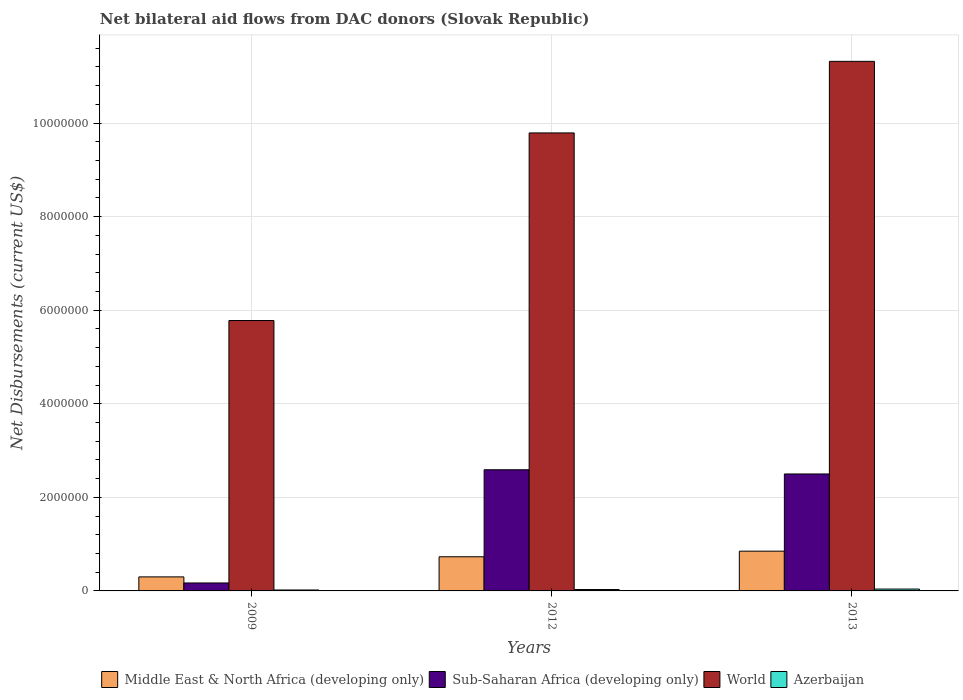How many different coloured bars are there?
Give a very brief answer. 4. What is the label of the 3rd group of bars from the left?
Make the answer very short. 2013. In how many cases, is the number of bars for a given year not equal to the number of legend labels?
Ensure brevity in your answer.  0. What is the net bilateral aid flows in Sub-Saharan Africa (developing only) in 2009?
Ensure brevity in your answer.  1.70e+05. Across all years, what is the maximum net bilateral aid flows in Sub-Saharan Africa (developing only)?
Offer a terse response. 2.59e+06. Across all years, what is the minimum net bilateral aid flows in Middle East & North Africa (developing only)?
Make the answer very short. 3.00e+05. What is the difference between the net bilateral aid flows in Sub-Saharan Africa (developing only) in 2009 and that in 2012?
Make the answer very short. -2.42e+06. What is the difference between the net bilateral aid flows in World in 2009 and the net bilateral aid flows in Sub-Saharan Africa (developing only) in 2012?
Keep it short and to the point. 3.19e+06. What is the average net bilateral aid flows in World per year?
Make the answer very short. 8.96e+06. In the year 2012, what is the difference between the net bilateral aid flows in World and net bilateral aid flows in Azerbaijan?
Keep it short and to the point. 9.76e+06. What is the ratio of the net bilateral aid flows in World in 2009 to that in 2013?
Your answer should be very brief. 0.51. What is the difference between the highest and the second highest net bilateral aid flows in Sub-Saharan Africa (developing only)?
Ensure brevity in your answer.  9.00e+04. What is the difference between the highest and the lowest net bilateral aid flows in Middle East & North Africa (developing only)?
Provide a short and direct response. 5.50e+05. In how many years, is the net bilateral aid flows in Azerbaijan greater than the average net bilateral aid flows in Azerbaijan taken over all years?
Offer a terse response. 1. Is the sum of the net bilateral aid flows in World in 2012 and 2013 greater than the maximum net bilateral aid flows in Middle East & North Africa (developing only) across all years?
Make the answer very short. Yes. What does the 2nd bar from the left in 2012 represents?
Make the answer very short. Sub-Saharan Africa (developing only). Is it the case that in every year, the sum of the net bilateral aid flows in Middle East & North Africa (developing only) and net bilateral aid flows in World is greater than the net bilateral aid flows in Sub-Saharan Africa (developing only)?
Your answer should be very brief. Yes. Are all the bars in the graph horizontal?
Your response must be concise. No. How many years are there in the graph?
Provide a succinct answer. 3. What is the difference between two consecutive major ticks on the Y-axis?
Your answer should be very brief. 2.00e+06. Where does the legend appear in the graph?
Offer a terse response. Bottom center. How many legend labels are there?
Your answer should be compact. 4. What is the title of the graph?
Ensure brevity in your answer.  Net bilateral aid flows from DAC donors (Slovak Republic). What is the label or title of the X-axis?
Give a very brief answer. Years. What is the label or title of the Y-axis?
Make the answer very short. Net Disbursements (current US$). What is the Net Disbursements (current US$) in Sub-Saharan Africa (developing only) in 2009?
Your answer should be very brief. 1.70e+05. What is the Net Disbursements (current US$) in World in 2009?
Offer a very short reply. 5.78e+06. What is the Net Disbursements (current US$) in Azerbaijan in 2009?
Offer a very short reply. 2.00e+04. What is the Net Disbursements (current US$) of Middle East & North Africa (developing only) in 2012?
Give a very brief answer. 7.30e+05. What is the Net Disbursements (current US$) of Sub-Saharan Africa (developing only) in 2012?
Make the answer very short. 2.59e+06. What is the Net Disbursements (current US$) of World in 2012?
Your answer should be very brief. 9.79e+06. What is the Net Disbursements (current US$) of Middle East & North Africa (developing only) in 2013?
Keep it short and to the point. 8.50e+05. What is the Net Disbursements (current US$) in Sub-Saharan Africa (developing only) in 2013?
Provide a short and direct response. 2.50e+06. What is the Net Disbursements (current US$) in World in 2013?
Ensure brevity in your answer.  1.13e+07. What is the Net Disbursements (current US$) of Azerbaijan in 2013?
Give a very brief answer. 4.00e+04. Across all years, what is the maximum Net Disbursements (current US$) in Middle East & North Africa (developing only)?
Offer a very short reply. 8.50e+05. Across all years, what is the maximum Net Disbursements (current US$) of Sub-Saharan Africa (developing only)?
Your response must be concise. 2.59e+06. Across all years, what is the maximum Net Disbursements (current US$) in World?
Make the answer very short. 1.13e+07. Across all years, what is the minimum Net Disbursements (current US$) of World?
Keep it short and to the point. 5.78e+06. Across all years, what is the minimum Net Disbursements (current US$) in Azerbaijan?
Your answer should be compact. 2.00e+04. What is the total Net Disbursements (current US$) of Middle East & North Africa (developing only) in the graph?
Your answer should be compact. 1.88e+06. What is the total Net Disbursements (current US$) of Sub-Saharan Africa (developing only) in the graph?
Your response must be concise. 5.26e+06. What is the total Net Disbursements (current US$) in World in the graph?
Your response must be concise. 2.69e+07. What is the difference between the Net Disbursements (current US$) of Middle East & North Africa (developing only) in 2009 and that in 2012?
Offer a terse response. -4.30e+05. What is the difference between the Net Disbursements (current US$) of Sub-Saharan Africa (developing only) in 2009 and that in 2012?
Ensure brevity in your answer.  -2.42e+06. What is the difference between the Net Disbursements (current US$) of World in 2009 and that in 2012?
Give a very brief answer. -4.01e+06. What is the difference between the Net Disbursements (current US$) of Middle East & North Africa (developing only) in 2009 and that in 2013?
Your answer should be compact. -5.50e+05. What is the difference between the Net Disbursements (current US$) of Sub-Saharan Africa (developing only) in 2009 and that in 2013?
Provide a short and direct response. -2.33e+06. What is the difference between the Net Disbursements (current US$) in World in 2009 and that in 2013?
Your response must be concise. -5.54e+06. What is the difference between the Net Disbursements (current US$) in Azerbaijan in 2009 and that in 2013?
Provide a succinct answer. -2.00e+04. What is the difference between the Net Disbursements (current US$) of World in 2012 and that in 2013?
Offer a very short reply. -1.53e+06. What is the difference between the Net Disbursements (current US$) in Azerbaijan in 2012 and that in 2013?
Your answer should be compact. -10000. What is the difference between the Net Disbursements (current US$) of Middle East & North Africa (developing only) in 2009 and the Net Disbursements (current US$) of Sub-Saharan Africa (developing only) in 2012?
Offer a terse response. -2.29e+06. What is the difference between the Net Disbursements (current US$) in Middle East & North Africa (developing only) in 2009 and the Net Disbursements (current US$) in World in 2012?
Make the answer very short. -9.49e+06. What is the difference between the Net Disbursements (current US$) of Middle East & North Africa (developing only) in 2009 and the Net Disbursements (current US$) of Azerbaijan in 2012?
Give a very brief answer. 2.70e+05. What is the difference between the Net Disbursements (current US$) of Sub-Saharan Africa (developing only) in 2009 and the Net Disbursements (current US$) of World in 2012?
Provide a short and direct response. -9.62e+06. What is the difference between the Net Disbursements (current US$) of Sub-Saharan Africa (developing only) in 2009 and the Net Disbursements (current US$) of Azerbaijan in 2012?
Offer a very short reply. 1.40e+05. What is the difference between the Net Disbursements (current US$) of World in 2009 and the Net Disbursements (current US$) of Azerbaijan in 2012?
Make the answer very short. 5.75e+06. What is the difference between the Net Disbursements (current US$) in Middle East & North Africa (developing only) in 2009 and the Net Disbursements (current US$) in Sub-Saharan Africa (developing only) in 2013?
Provide a succinct answer. -2.20e+06. What is the difference between the Net Disbursements (current US$) in Middle East & North Africa (developing only) in 2009 and the Net Disbursements (current US$) in World in 2013?
Your answer should be compact. -1.10e+07. What is the difference between the Net Disbursements (current US$) of Middle East & North Africa (developing only) in 2009 and the Net Disbursements (current US$) of Azerbaijan in 2013?
Your answer should be compact. 2.60e+05. What is the difference between the Net Disbursements (current US$) in Sub-Saharan Africa (developing only) in 2009 and the Net Disbursements (current US$) in World in 2013?
Your answer should be very brief. -1.12e+07. What is the difference between the Net Disbursements (current US$) of Sub-Saharan Africa (developing only) in 2009 and the Net Disbursements (current US$) of Azerbaijan in 2013?
Your answer should be very brief. 1.30e+05. What is the difference between the Net Disbursements (current US$) in World in 2009 and the Net Disbursements (current US$) in Azerbaijan in 2013?
Keep it short and to the point. 5.74e+06. What is the difference between the Net Disbursements (current US$) in Middle East & North Africa (developing only) in 2012 and the Net Disbursements (current US$) in Sub-Saharan Africa (developing only) in 2013?
Provide a short and direct response. -1.77e+06. What is the difference between the Net Disbursements (current US$) in Middle East & North Africa (developing only) in 2012 and the Net Disbursements (current US$) in World in 2013?
Your answer should be compact. -1.06e+07. What is the difference between the Net Disbursements (current US$) of Middle East & North Africa (developing only) in 2012 and the Net Disbursements (current US$) of Azerbaijan in 2013?
Give a very brief answer. 6.90e+05. What is the difference between the Net Disbursements (current US$) of Sub-Saharan Africa (developing only) in 2012 and the Net Disbursements (current US$) of World in 2013?
Ensure brevity in your answer.  -8.73e+06. What is the difference between the Net Disbursements (current US$) in Sub-Saharan Africa (developing only) in 2012 and the Net Disbursements (current US$) in Azerbaijan in 2013?
Ensure brevity in your answer.  2.55e+06. What is the difference between the Net Disbursements (current US$) in World in 2012 and the Net Disbursements (current US$) in Azerbaijan in 2013?
Offer a terse response. 9.75e+06. What is the average Net Disbursements (current US$) of Middle East & North Africa (developing only) per year?
Make the answer very short. 6.27e+05. What is the average Net Disbursements (current US$) of Sub-Saharan Africa (developing only) per year?
Your answer should be compact. 1.75e+06. What is the average Net Disbursements (current US$) in World per year?
Give a very brief answer. 8.96e+06. In the year 2009, what is the difference between the Net Disbursements (current US$) of Middle East & North Africa (developing only) and Net Disbursements (current US$) of Sub-Saharan Africa (developing only)?
Keep it short and to the point. 1.30e+05. In the year 2009, what is the difference between the Net Disbursements (current US$) of Middle East & North Africa (developing only) and Net Disbursements (current US$) of World?
Your response must be concise. -5.48e+06. In the year 2009, what is the difference between the Net Disbursements (current US$) of Middle East & North Africa (developing only) and Net Disbursements (current US$) of Azerbaijan?
Provide a succinct answer. 2.80e+05. In the year 2009, what is the difference between the Net Disbursements (current US$) in Sub-Saharan Africa (developing only) and Net Disbursements (current US$) in World?
Your answer should be very brief. -5.61e+06. In the year 2009, what is the difference between the Net Disbursements (current US$) of World and Net Disbursements (current US$) of Azerbaijan?
Make the answer very short. 5.76e+06. In the year 2012, what is the difference between the Net Disbursements (current US$) in Middle East & North Africa (developing only) and Net Disbursements (current US$) in Sub-Saharan Africa (developing only)?
Your answer should be very brief. -1.86e+06. In the year 2012, what is the difference between the Net Disbursements (current US$) in Middle East & North Africa (developing only) and Net Disbursements (current US$) in World?
Make the answer very short. -9.06e+06. In the year 2012, what is the difference between the Net Disbursements (current US$) of Sub-Saharan Africa (developing only) and Net Disbursements (current US$) of World?
Offer a very short reply. -7.20e+06. In the year 2012, what is the difference between the Net Disbursements (current US$) of Sub-Saharan Africa (developing only) and Net Disbursements (current US$) of Azerbaijan?
Your answer should be very brief. 2.56e+06. In the year 2012, what is the difference between the Net Disbursements (current US$) of World and Net Disbursements (current US$) of Azerbaijan?
Your response must be concise. 9.76e+06. In the year 2013, what is the difference between the Net Disbursements (current US$) of Middle East & North Africa (developing only) and Net Disbursements (current US$) of Sub-Saharan Africa (developing only)?
Offer a very short reply. -1.65e+06. In the year 2013, what is the difference between the Net Disbursements (current US$) in Middle East & North Africa (developing only) and Net Disbursements (current US$) in World?
Give a very brief answer. -1.05e+07. In the year 2013, what is the difference between the Net Disbursements (current US$) of Middle East & North Africa (developing only) and Net Disbursements (current US$) of Azerbaijan?
Your answer should be very brief. 8.10e+05. In the year 2013, what is the difference between the Net Disbursements (current US$) of Sub-Saharan Africa (developing only) and Net Disbursements (current US$) of World?
Give a very brief answer. -8.82e+06. In the year 2013, what is the difference between the Net Disbursements (current US$) in Sub-Saharan Africa (developing only) and Net Disbursements (current US$) in Azerbaijan?
Keep it short and to the point. 2.46e+06. In the year 2013, what is the difference between the Net Disbursements (current US$) in World and Net Disbursements (current US$) in Azerbaijan?
Ensure brevity in your answer.  1.13e+07. What is the ratio of the Net Disbursements (current US$) of Middle East & North Africa (developing only) in 2009 to that in 2012?
Your answer should be compact. 0.41. What is the ratio of the Net Disbursements (current US$) of Sub-Saharan Africa (developing only) in 2009 to that in 2012?
Give a very brief answer. 0.07. What is the ratio of the Net Disbursements (current US$) in World in 2009 to that in 2012?
Keep it short and to the point. 0.59. What is the ratio of the Net Disbursements (current US$) of Azerbaijan in 2009 to that in 2012?
Ensure brevity in your answer.  0.67. What is the ratio of the Net Disbursements (current US$) of Middle East & North Africa (developing only) in 2009 to that in 2013?
Your answer should be very brief. 0.35. What is the ratio of the Net Disbursements (current US$) of Sub-Saharan Africa (developing only) in 2009 to that in 2013?
Ensure brevity in your answer.  0.07. What is the ratio of the Net Disbursements (current US$) of World in 2009 to that in 2013?
Keep it short and to the point. 0.51. What is the ratio of the Net Disbursements (current US$) of Middle East & North Africa (developing only) in 2012 to that in 2013?
Your answer should be very brief. 0.86. What is the ratio of the Net Disbursements (current US$) in Sub-Saharan Africa (developing only) in 2012 to that in 2013?
Make the answer very short. 1.04. What is the ratio of the Net Disbursements (current US$) of World in 2012 to that in 2013?
Your answer should be compact. 0.86. What is the ratio of the Net Disbursements (current US$) in Azerbaijan in 2012 to that in 2013?
Give a very brief answer. 0.75. What is the difference between the highest and the second highest Net Disbursements (current US$) of World?
Provide a short and direct response. 1.53e+06. What is the difference between the highest and the second highest Net Disbursements (current US$) of Azerbaijan?
Your answer should be compact. 10000. What is the difference between the highest and the lowest Net Disbursements (current US$) of Middle East & North Africa (developing only)?
Keep it short and to the point. 5.50e+05. What is the difference between the highest and the lowest Net Disbursements (current US$) in Sub-Saharan Africa (developing only)?
Offer a very short reply. 2.42e+06. What is the difference between the highest and the lowest Net Disbursements (current US$) of World?
Ensure brevity in your answer.  5.54e+06. What is the difference between the highest and the lowest Net Disbursements (current US$) of Azerbaijan?
Offer a very short reply. 2.00e+04. 